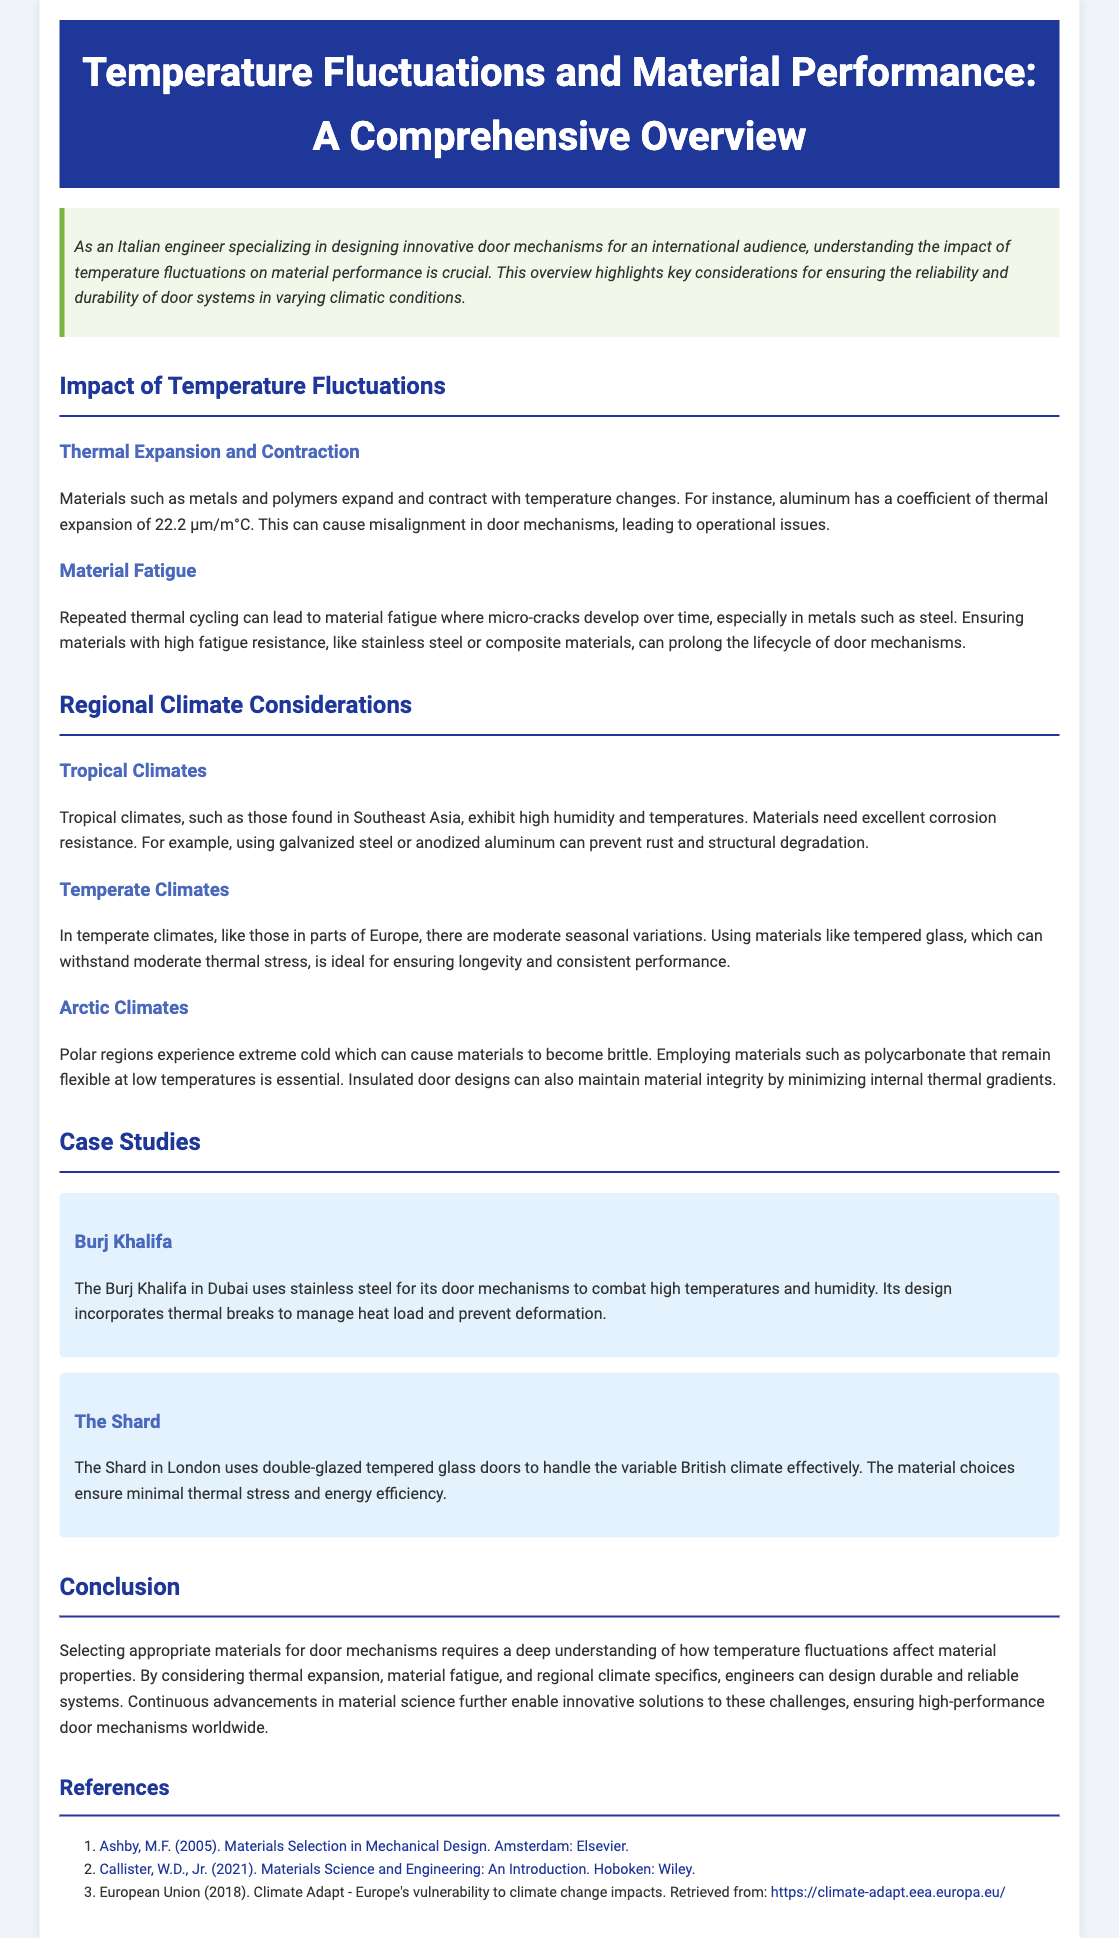What is the title of the document? The title of the document is located in the header section.
Answer: Temperature Fluctuations and Material Performance: A Comprehensive Overview What coefficient of thermal expansion does aluminum have? This value is specified in the section discussing thermal expansion and contraction.
Answer: 22.2 μm/m°C Which material is recommended for tropical climates to prevent rust? The document mentions specific materials suitable for tropical climates.
Answer: Galvanized steel What case study features the use of double-glazed tempered glass doors? The case study section provides specific building examples.
Answer: The Shard What material is highlighted for minimizing thermal stress in temperate climates? The text specifies the preferred material for temperate climates.
Answer: Tempered glass What happens to materials in arctic climates? The document describes the effects of extreme cold on materials.
Answer: Become brittle How can engineers ensure the reliability of door systems in varying climatic conditions? This is summarized in the conclusion about material selection considerations.
Answer: By considering thermal expansion, material fatigue, and regional climate specifics Which city is mentioned in relation to the Burj Khalifa case study? The case study specifies the location of the Burj Khalifa.
Answer: Dubai 